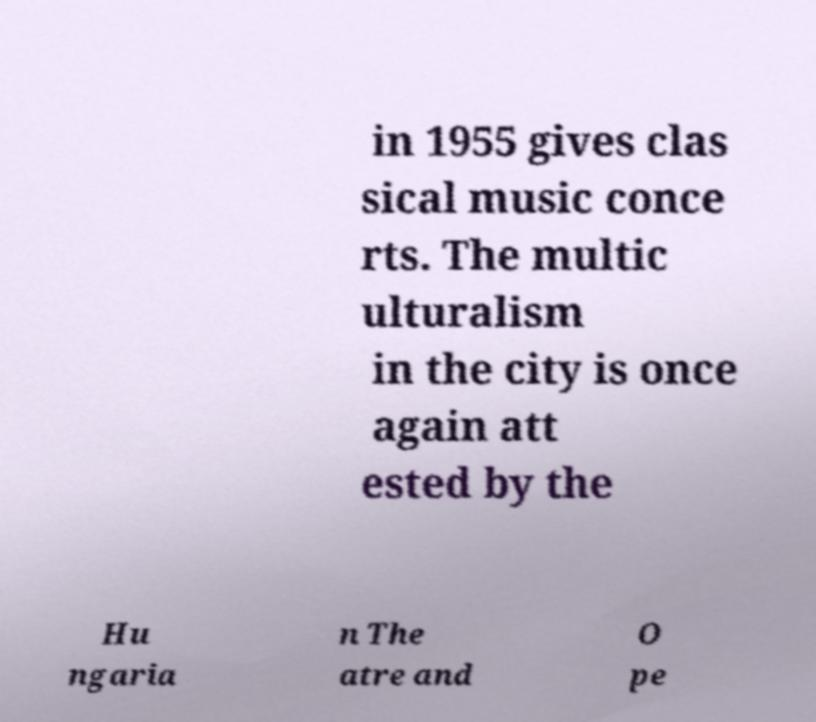There's text embedded in this image that I need extracted. Can you transcribe it verbatim? in 1955 gives clas sical music conce rts. The multic ulturalism in the city is once again att ested by the Hu ngaria n The atre and O pe 